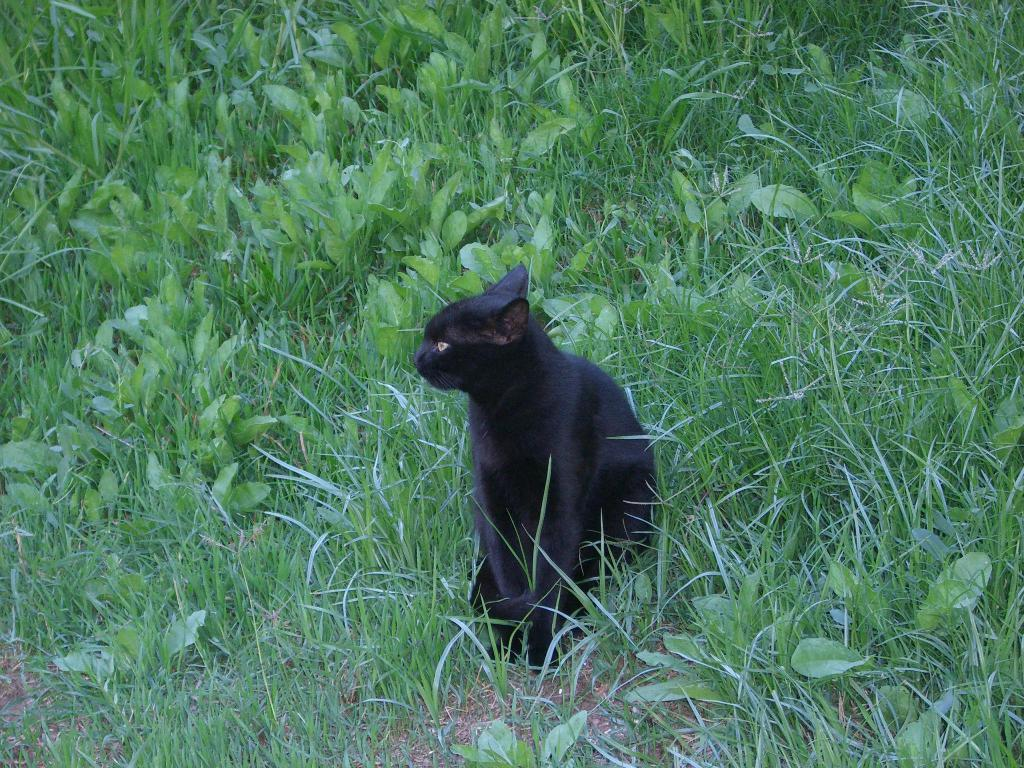What is the main subject in the center of the image? There is a cat in the center of the image. What can be seen in the background of the image? There are plants and grass visible in the background of the image. What type of breakfast is the cat eating in the image? There is no indication of the cat eating breakfast in the image. 